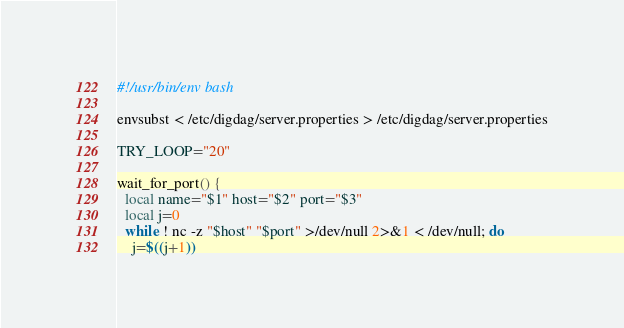Convert code to text. <code><loc_0><loc_0><loc_500><loc_500><_Bash_>#!/usr/bin/env bash

envsubst < /etc/digdag/server.properties > /etc/digdag/server.properties

TRY_LOOP="20"

wait_for_port() {
  local name="$1" host="$2" port="$3"
  local j=0
  while ! nc -z "$host" "$port" >/dev/null 2>&1 < /dev/null; do
    j=$((j+1))</code> 